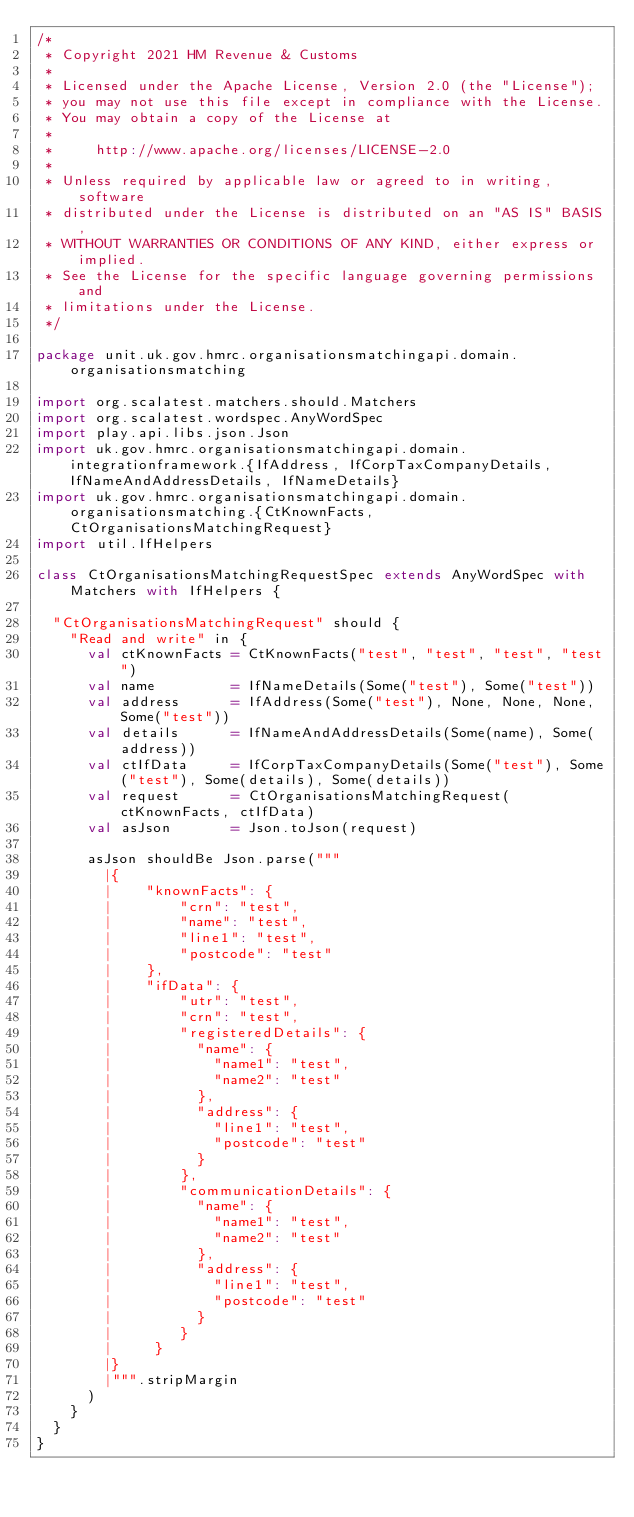<code> <loc_0><loc_0><loc_500><loc_500><_Scala_>/*
 * Copyright 2021 HM Revenue & Customs
 *
 * Licensed under the Apache License, Version 2.0 (the "License");
 * you may not use this file except in compliance with the License.
 * You may obtain a copy of the License at
 *
 *     http://www.apache.org/licenses/LICENSE-2.0
 *
 * Unless required by applicable law or agreed to in writing, software
 * distributed under the License is distributed on an "AS IS" BASIS,
 * WITHOUT WARRANTIES OR CONDITIONS OF ANY KIND, either express or implied.
 * See the License for the specific language governing permissions and
 * limitations under the License.
 */

package unit.uk.gov.hmrc.organisationsmatchingapi.domain.organisationsmatching

import org.scalatest.matchers.should.Matchers
import org.scalatest.wordspec.AnyWordSpec
import play.api.libs.json.Json
import uk.gov.hmrc.organisationsmatchingapi.domain.integrationframework.{IfAddress, IfCorpTaxCompanyDetails, IfNameAndAddressDetails, IfNameDetails}
import uk.gov.hmrc.organisationsmatchingapi.domain.organisationsmatching.{CtKnownFacts, CtOrganisationsMatchingRequest}
import util.IfHelpers

class CtOrganisationsMatchingRequestSpec extends AnyWordSpec with Matchers with IfHelpers {

  "CtOrganisationsMatchingRequest" should {
    "Read and write" in {
      val ctKnownFacts = CtKnownFacts("test", "test", "test", "test")
      val name         = IfNameDetails(Some("test"), Some("test"))
      val address      = IfAddress(Some("test"), None, None, None, Some("test"))
      val details      = IfNameAndAddressDetails(Some(name), Some(address))
      val ctIfData     = IfCorpTaxCompanyDetails(Some("test"), Some("test"), Some(details), Some(details))
      val request      = CtOrganisationsMatchingRequest(ctKnownFacts, ctIfData)
      val asJson       = Json.toJson(request)

      asJson shouldBe Json.parse("""
        |{
        |    "knownFacts": {
        |        "crn": "test",
        |        "name": "test",
        |        "line1": "test",
        |        "postcode": "test"
        |    },
        |    "ifData": {
        |        "utr": "test",
        |        "crn": "test",
        |        "registeredDetails": {
        |          "name": {
        |            "name1": "test",
        |            "name2": "test"
        |          },
        |          "address": {
        |            "line1": "test",
        |            "postcode": "test"
        |          }
        |        },
        |        "communicationDetails": {
        |          "name": {
        |            "name1": "test",
        |            "name2": "test"
        |          },
        |          "address": {
        |            "line1": "test",
        |            "postcode": "test"
        |          }
        |        }
        |     }
        |}
        |""".stripMargin
      )
    }
  }
}
</code> 